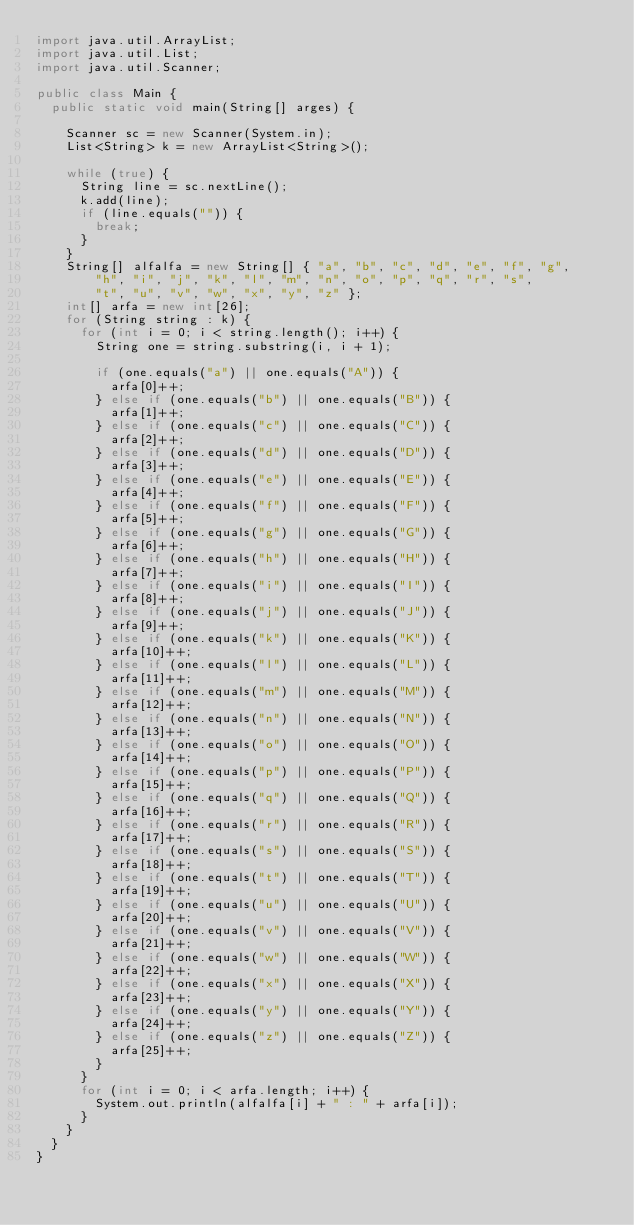Convert code to text. <code><loc_0><loc_0><loc_500><loc_500><_Java_>import java.util.ArrayList;
import java.util.List;
import java.util.Scanner;

public class Main {
	public static void main(String[] arges) {

		Scanner sc = new Scanner(System.in);
		List<String> k = new ArrayList<String>();

		while (true) {
			String line = sc.nextLine();
			k.add(line);
			if (line.equals("")) {
				break;
			}
		}
		String[] alfalfa = new String[] { "a", "b", "c", "d", "e", "f", "g",
				"h", "i", "j", "k", "l", "m", "n", "o", "p", "q", "r", "s",
				"t", "u", "v", "w", "x", "y", "z" };
		int[] arfa = new int[26];
		for (String string : k) {
			for (int i = 0; i < string.length(); i++) {
				String one = string.substring(i, i + 1);

				if (one.equals("a") || one.equals("A")) {
					arfa[0]++;
				} else if (one.equals("b") || one.equals("B")) {
					arfa[1]++;
				} else if (one.equals("c") || one.equals("C")) {
					arfa[2]++;
				} else if (one.equals("d") || one.equals("D")) {
					arfa[3]++;
				} else if (one.equals("e") || one.equals("E")) {
					arfa[4]++;
				} else if (one.equals("f") || one.equals("F")) {
					arfa[5]++;
				} else if (one.equals("g") || one.equals("G")) {
					arfa[6]++;
				} else if (one.equals("h") || one.equals("H")) {
					arfa[7]++;
				} else if (one.equals("i") || one.equals("I")) {
					arfa[8]++;
				} else if (one.equals("j") || one.equals("J")) {
					arfa[9]++;
				} else if (one.equals("k") || one.equals("K")) {
					arfa[10]++;
				} else if (one.equals("l") || one.equals("L")) {
					arfa[11]++;
				} else if (one.equals("m") || one.equals("M")) {
					arfa[12]++;
				} else if (one.equals("n") || one.equals("N")) {
					arfa[13]++;
				} else if (one.equals("o") || one.equals("O")) {
					arfa[14]++;
				} else if (one.equals("p") || one.equals("P")) {
					arfa[15]++;
				} else if (one.equals("q") || one.equals("Q")) {
					arfa[16]++;
				} else if (one.equals("r") || one.equals("R")) {
					arfa[17]++;
				} else if (one.equals("s") || one.equals("S")) {
					arfa[18]++;
				} else if (one.equals("t") || one.equals("T")) {
					arfa[19]++;
				} else if (one.equals("u") || one.equals("U")) {
					arfa[20]++;
				} else if (one.equals("v") || one.equals("V")) {
					arfa[21]++;
				} else if (one.equals("w") || one.equals("W")) {
					arfa[22]++;
				} else if (one.equals("x") || one.equals("X")) {
					arfa[23]++;
				} else if (one.equals("y") || one.equals("Y")) {
					arfa[24]++;
				} else if (one.equals("z") || one.equals("Z")) {
					arfa[25]++;
				}
			}
			for (int i = 0; i < arfa.length; i++) {
				System.out.println(alfalfa[i] + " : " + arfa[i]);
			}
		}
	}
}</code> 